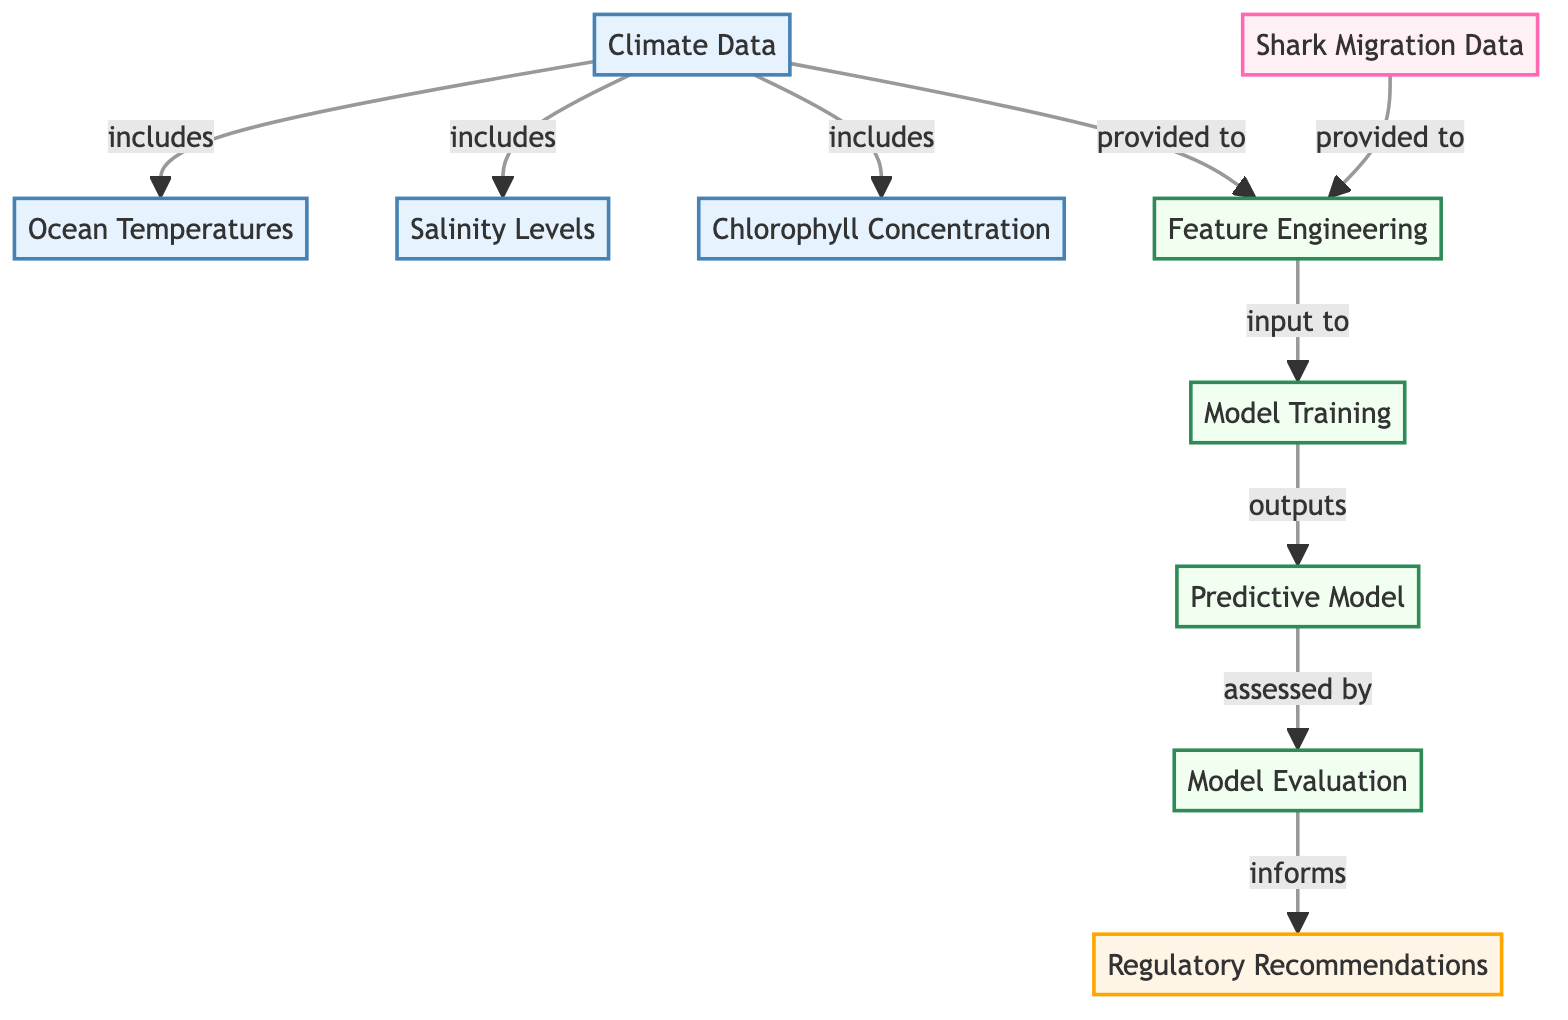What are the climate variables included in the climate data? The diagram shows three climate variables: Ocean Temperatures, Salinity Levels, and Chlorophyll Concentration, all of which are directly connected to the Climate Data node, indicating they are its components.
Answer: Ocean Temperatures, Salinity Levels, Chlorophyll Concentration How many nodes represent the model training process? In the diagram, there are three nodes that represent parts of the model training process: Feature Engineering, Model Training, and Model Evaluation. These nodes collectively depict the training workflow within the machine learning context.
Answer: 3 What is the final output of the predictive model evaluation? The output of the Model Evaluation node is directed toward the Regulatory Recommendations node, indicating that this is the conclusion of the modeling process, where the evaluated predictions lead to recommendations for regulations.
Answer: Regulatory Recommendations Which data is provided to feature engineering alongside climate data? The diagram illustrates that Migration Data is provided to Feature Engineering in addition to Climate Data. This means both data sources are crucial for constructing the features used in the model.
Answer: Migration Data What informs regulatory recommendations in the diagram? The diagram indicates that the Model Evaluation process informs the Regulatory Recommendations. This relationship shows that the results from evaluating the predictive model shape the recommendations made for shark population management.
Answer: Model Evaluation How many climate-related nodes are present in the diagram? There are four climate-related nodes depicted in the diagram: Climate Data, Ocean Temperatures, Salinity Levels, and Chlorophyll Concentration, which highlights the different aspects of climate data relevant to the analysis.
Answer: 4 What does the predictive model receive as input after feature engineering? The diagram reveals that after Feature Engineering, the output is provided to the Model Training node, indicating that it is the next step in utilizing the engineered features to train a predictive model.
Answer: Model Training What is the first step in the process shown in the diagram? The initial step in the diagram involves the Climate Data node, which serves as the starting point for gathering essential climate variables and connecting them to other components in the flow.
Answer: Climate Data 